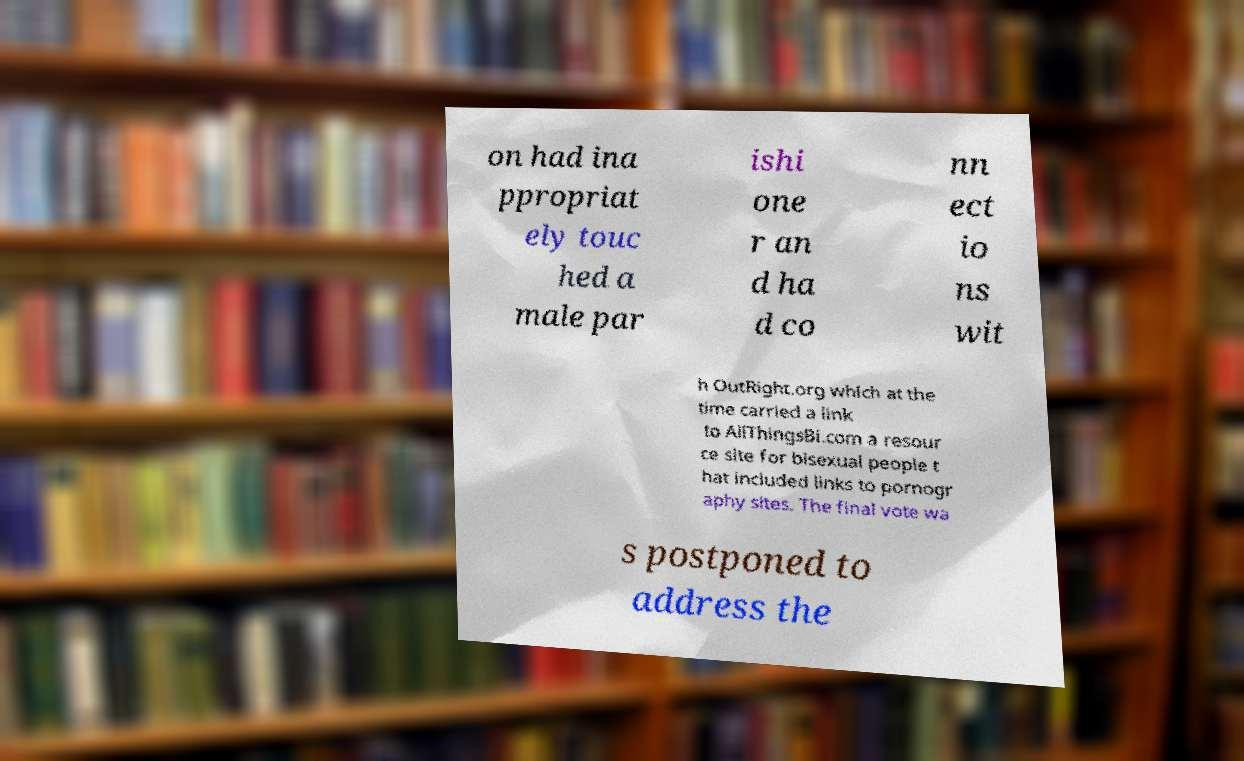I need the written content from this picture converted into text. Can you do that? on had ina ppropriat ely touc hed a male par ishi one r an d ha d co nn ect io ns wit h OutRight.org which at the time carried a link to AllThingsBi.com a resour ce site for bisexual people t hat included links to pornogr aphy sites. The final vote wa s postponed to address the 